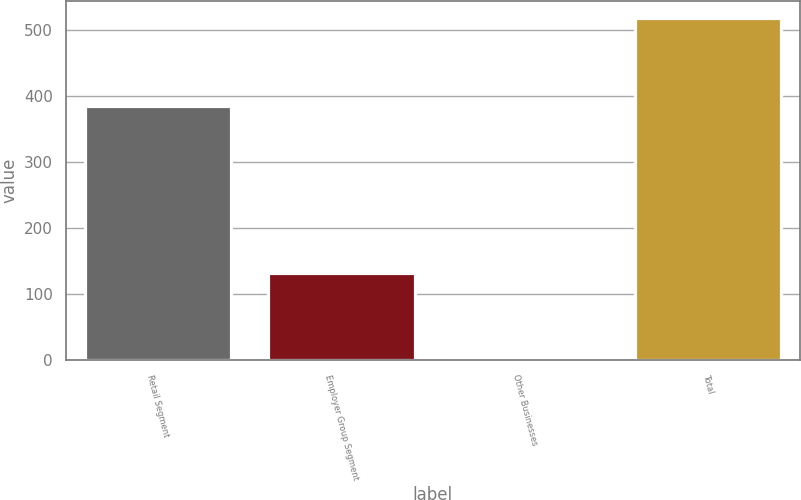Convert chart to OTSL. <chart><loc_0><loc_0><loc_500><loc_500><bar_chart><fcel>Retail Segment<fcel>Employer Group Segment<fcel>Other Businesses<fcel>Total<nl><fcel>385<fcel>132<fcel>1<fcel>518<nl></chart> 